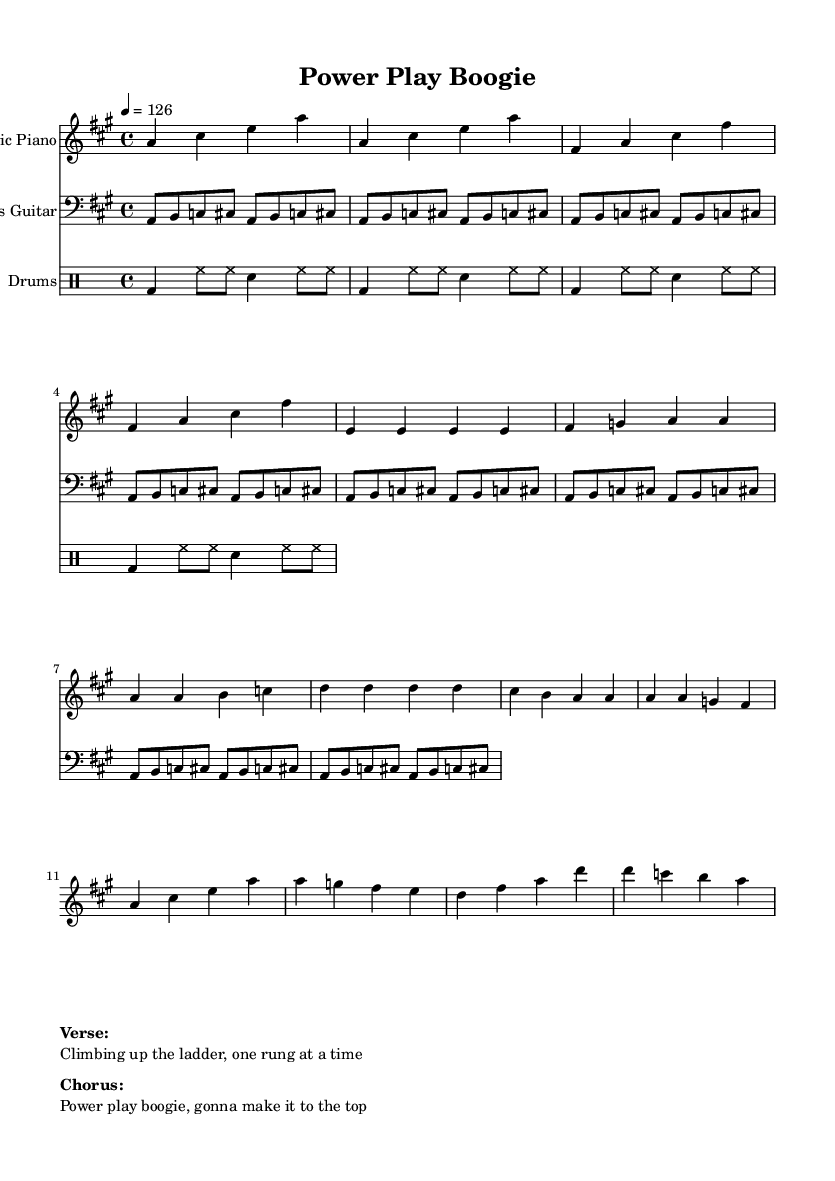What is the key signature of this music? The key signature reveals that there are three sharps (F#, C#, and G#), which indicates that the piece is in A major.
Answer: A major What is the time signature of the piece? The time signature displayed at the beginning of the music is 4/4, indicating that there are four beats per measure, and each quarter note receives one beat.
Answer: 4/4 What is the tempo marking for this piece? The tempo is indicated at the beginning with a marking of 126, meaning the piece should be played at 126 beats per minute, which gives it an upbeat character suitable for disco music.
Answer: 126 How many measures are in the verse melody? Counting the measures in the verse melody as notated, there are a total of 8 measures present in that section.
Answer: 8 What instruments are used in this piece? The music indicates the usage of three distinct instruments: Electric Piano, Bass Guitar, and Drums, which are common in disco arrangements to provide melody, harmony, and rhythm.
Answer: Electric Piano, Bass Guitar, Drums What does the chorus lyric emphasize about ambition? The chorus lyric contains the phrase "gonna make it to the top," which emphasizes personal ambition and the excitement of striving for success in a political context.
Answer: "gonna make it to the top." How many times is the bass line repeated? The bass line is indicated to be repeated 16 times, as shown by the repeated text "repeat unfold 16," suggesting a driving, consistent bass rhythm typical of disco music.
Answer: 16 